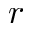<formula> <loc_0><loc_0><loc_500><loc_500>r</formula> 